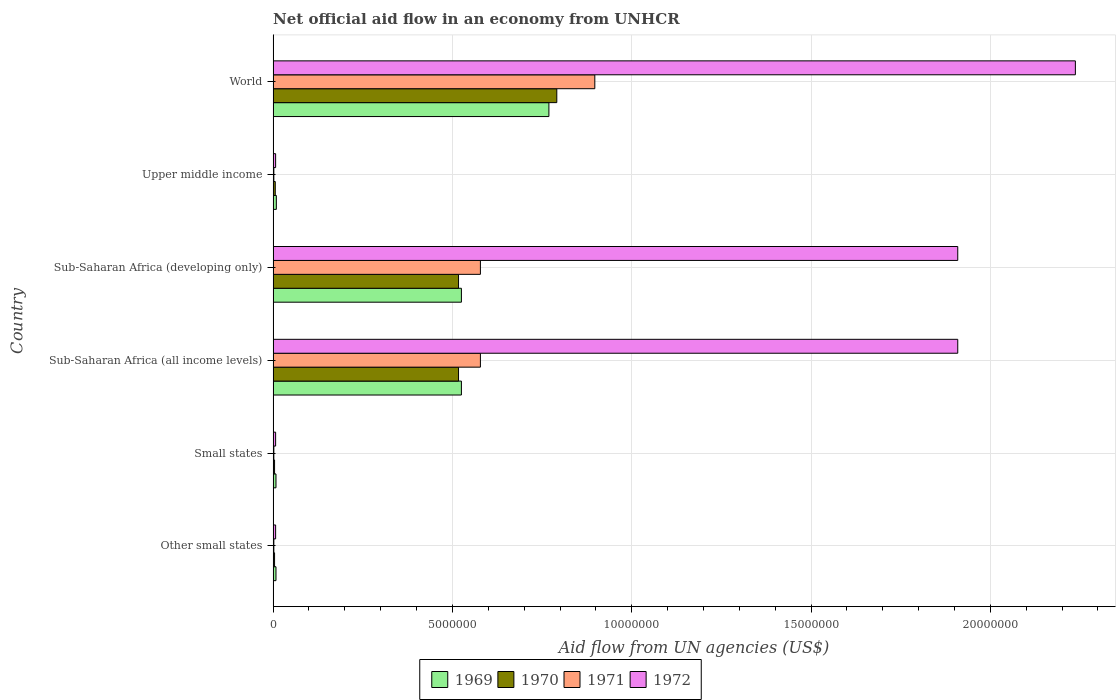How many groups of bars are there?
Provide a succinct answer. 6. Are the number of bars per tick equal to the number of legend labels?
Provide a short and direct response. Yes. How many bars are there on the 4th tick from the top?
Provide a succinct answer. 4. How many bars are there on the 2nd tick from the bottom?
Make the answer very short. 4. What is the label of the 1st group of bars from the top?
Provide a short and direct response. World. In how many cases, is the number of bars for a given country not equal to the number of legend labels?
Ensure brevity in your answer.  0. What is the net official aid flow in 1971 in Sub-Saharan Africa (all income levels)?
Keep it short and to the point. 5.78e+06. Across all countries, what is the maximum net official aid flow in 1972?
Your answer should be compact. 2.24e+07. Across all countries, what is the minimum net official aid flow in 1969?
Keep it short and to the point. 8.00e+04. In which country was the net official aid flow in 1971 maximum?
Keep it short and to the point. World. In which country was the net official aid flow in 1972 minimum?
Your response must be concise. Other small states. What is the total net official aid flow in 1971 in the graph?
Your answer should be compact. 2.06e+07. What is the difference between the net official aid flow in 1970 in Sub-Saharan Africa (developing only) and that in World?
Give a very brief answer. -2.74e+06. What is the difference between the net official aid flow in 1970 in Sub-Saharan Africa (all income levels) and the net official aid flow in 1969 in Upper middle income?
Ensure brevity in your answer.  5.08e+06. What is the average net official aid flow in 1971 per country?
Provide a succinct answer. 3.43e+06. What is the ratio of the net official aid flow in 1971 in Small states to that in World?
Your response must be concise. 0. Is the difference between the net official aid flow in 1971 in Sub-Saharan Africa (all income levels) and Sub-Saharan Africa (developing only) greater than the difference between the net official aid flow in 1972 in Sub-Saharan Africa (all income levels) and Sub-Saharan Africa (developing only)?
Provide a succinct answer. No. What is the difference between the highest and the second highest net official aid flow in 1970?
Provide a short and direct response. 2.74e+06. What is the difference between the highest and the lowest net official aid flow in 1972?
Ensure brevity in your answer.  2.23e+07. In how many countries, is the net official aid flow in 1971 greater than the average net official aid flow in 1971 taken over all countries?
Your response must be concise. 3. Is the sum of the net official aid flow in 1970 in Other small states and Sub-Saharan Africa (all income levels) greater than the maximum net official aid flow in 1972 across all countries?
Provide a succinct answer. No. Is it the case that in every country, the sum of the net official aid flow in 1969 and net official aid flow in 1972 is greater than the sum of net official aid flow in 1970 and net official aid flow in 1971?
Keep it short and to the point. No. What does the 4th bar from the top in World represents?
Provide a succinct answer. 1969. What does the 2nd bar from the bottom in World represents?
Your answer should be compact. 1970. Is it the case that in every country, the sum of the net official aid flow in 1969 and net official aid flow in 1970 is greater than the net official aid flow in 1971?
Give a very brief answer. Yes. Are all the bars in the graph horizontal?
Give a very brief answer. Yes. Are the values on the major ticks of X-axis written in scientific E-notation?
Ensure brevity in your answer.  No. Does the graph contain grids?
Provide a short and direct response. Yes. Where does the legend appear in the graph?
Make the answer very short. Bottom center. How many legend labels are there?
Make the answer very short. 4. What is the title of the graph?
Provide a succinct answer. Net official aid flow in an economy from UNHCR. Does "2009" appear as one of the legend labels in the graph?
Your answer should be very brief. No. What is the label or title of the X-axis?
Offer a terse response. Aid flow from UN agencies (US$). What is the label or title of the Y-axis?
Your answer should be compact. Country. What is the Aid flow from UN agencies (US$) of 1970 in Other small states?
Ensure brevity in your answer.  4.00e+04. What is the Aid flow from UN agencies (US$) in 1972 in Other small states?
Your answer should be very brief. 7.00e+04. What is the Aid flow from UN agencies (US$) of 1970 in Small states?
Keep it short and to the point. 4.00e+04. What is the Aid flow from UN agencies (US$) in 1971 in Small states?
Ensure brevity in your answer.  2.00e+04. What is the Aid flow from UN agencies (US$) of 1969 in Sub-Saharan Africa (all income levels)?
Ensure brevity in your answer.  5.25e+06. What is the Aid flow from UN agencies (US$) in 1970 in Sub-Saharan Africa (all income levels)?
Keep it short and to the point. 5.17e+06. What is the Aid flow from UN agencies (US$) of 1971 in Sub-Saharan Africa (all income levels)?
Keep it short and to the point. 5.78e+06. What is the Aid flow from UN agencies (US$) in 1972 in Sub-Saharan Africa (all income levels)?
Offer a very short reply. 1.91e+07. What is the Aid flow from UN agencies (US$) in 1969 in Sub-Saharan Africa (developing only)?
Make the answer very short. 5.25e+06. What is the Aid flow from UN agencies (US$) of 1970 in Sub-Saharan Africa (developing only)?
Provide a succinct answer. 5.17e+06. What is the Aid flow from UN agencies (US$) of 1971 in Sub-Saharan Africa (developing only)?
Provide a succinct answer. 5.78e+06. What is the Aid flow from UN agencies (US$) in 1972 in Sub-Saharan Africa (developing only)?
Provide a succinct answer. 1.91e+07. What is the Aid flow from UN agencies (US$) of 1970 in Upper middle income?
Keep it short and to the point. 6.00e+04. What is the Aid flow from UN agencies (US$) in 1969 in World?
Give a very brief answer. 7.69e+06. What is the Aid flow from UN agencies (US$) in 1970 in World?
Your answer should be compact. 7.91e+06. What is the Aid flow from UN agencies (US$) in 1971 in World?
Your answer should be compact. 8.97e+06. What is the Aid flow from UN agencies (US$) in 1972 in World?
Your answer should be compact. 2.24e+07. Across all countries, what is the maximum Aid flow from UN agencies (US$) of 1969?
Offer a terse response. 7.69e+06. Across all countries, what is the maximum Aid flow from UN agencies (US$) of 1970?
Give a very brief answer. 7.91e+06. Across all countries, what is the maximum Aid flow from UN agencies (US$) of 1971?
Give a very brief answer. 8.97e+06. Across all countries, what is the maximum Aid flow from UN agencies (US$) in 1972?
Your answer should be very brief. 2.24e+07. What is the total Aid flow from UN agencies (US$) in 1969 in the graph?
Give a very brief answer. 1.84e+07. What is the total Aid flow from UN agencies (US$) in 1970 in the graph?
Your answer should be very brief. 1.84e+07. What is the total Aid flow from UN agencies (US$) of 1971 in the graph?
Offer a very short reply. 2.06e+07. What is the total Aid flow from UN agencies (US$) of 1972 in the graph?
Your answer should be very brief. 6.08e+07. What is the difference between the Aid flow from UN agencies (US$) of 1969 in Other small states and that in Sub-Saharan Africa (all income levels)?
Your answer should be compact. -5.17e+06. What is the difference between the Aid flow from UN agencies (US$) of 1970 in Other small states and that in Sub-Saharan Africa (all income levels)?
Keep it short and to the point. -5.13e+06. What is the difference between the Aid flow from UN agencies (US$) of 1971 in Other small states and that in Sub-Saharan Africa (all income levels)?
Offer a very short reply. -5.76e+06. What is the difference between the Aid flow from UN agencies (US$) of 1972 in Other small states and that in Sub-Saharan Africa (all income levels)?
Keep it short and to the point. -1.90e+07. What is the difference between the Aid flow from UN agencies (US$) of 1969 in Other small states and that in Sub-Saharan Africa (developing only)?
Your answer should be compact. -5.17e+06. What is the difference between the Aid flow from UN agencies (US$) of 1970 in Other small states and that in Sub-Saharan Africa (developing only)?
Ensure brevity in your answer.  -5.13e+06. What is the difference between the Aid flow from UN agencies (US$) of 1971 in Other small states and that in Sub-Saharan Africa (developing only)?
Give a very brief answer. -5.76e+06. What is the difference between the Aid flow from UN agencies (US$) in 1972 in Other small states and that in Sub-Saharan Africa (developing only)?
Make the answer very short. -1.90e+07. What is the difference between the Aid flow from UN agencies (US$) in 1971 in Other small states and that in Upper middle income?
Provide a succinct answer. 0. What is the difference between the Aid flow from UN agencies (US$) in 1972 in Other small states and that in Upper middle income?
Offer a very short reply. 0. What is the difference between the Aid flow from UN agencies (US$) in 1969 in Other small states and that in World?
Provide a short and direct response. -7.61e+06. What is the difference between the Aid flow from UN agencies (US$) of 1970 in Other small states and that in World?
Your response must be concise. -7.87e+06. What is the difference between the Aid flow from UN agencies (US$) of 1971 in Other small states and that in World?
Provide a succinct answer. -8.95e+06. What is the difference between the Aid flow from UN agencies (US$) in 1972 in Other small states and that in World?
Make the answer very short. -2.23e+07. What is the difference between the Aid flow from UN agencies (US$) in 1969 in Small states and that in Sub-Saharan Africa (all income levels)?
Offer a terse response. -5.17e+06. What is the difference between the Aid flow from UN agencies (US$) of 1970 in Small states and that in Sub-Saharan Africa (all income levels)?
Your answer should be compact. -5.13e+06. What is the difference between the Aid flow from UN agencies (US$) of 1971 in Small states and that in Sub-Saharan Africa (all income levels)?
Your answer should be compact. -5.76e+06. What is the difference between the Aid flow from UN agencies (US$) in 1972 in Small states and that in Sub-Saharan Africa (all income levels)?
Ensure brevity in your answer.  -1.90e+07. What is the difference between the Aid flow from UN agencies (US$) of 1969 in Small states and that in Sub-Saharan Africa (developing only)?
Offer a terse response. -5.17e+06. What is the difference between the Aid flow from UN agencies (US$) in 1970 in Small states and that in Sub-Saharan Africa (developing only)?
Offer a terse response. -5.13e+06. What is the difference between the Aid flow from UN agencies (US$) of 1971 in Small states and that in Sub-Saharan Africa (developing only)?
Your answer should be compact. -5.76e+06. What is the difference between the Aid flow from UN agencies (US$) of 1972 in Small states and that in Sub-Saharan Africa (developing only)?
Offer a very short reply. -1.90e+07. What is the difference between the Aid flow from UN agencies (US$) of 1971 in Small states and that in Upper middle income?
Your answer should be compact. 0. What is the difference between the Aid flow from UN agencies (US$) of 1972 in Small states and that in Upper middle income?
Your response must be concise. 0. What is the difference between the Aid flow from UN agencies (US$) of 1969 in Small states and that in World?
Your response must be concise. -7.61e+06. What is the difference between the Aid flow from UN agencies (US$) in 1970 in Small states and that in World?
Offer a very short reply. -7.87e+06. What is the difference between the Aid flow from UN agencies (US$) in 1971 in Small states and that in World?
Your response must be concise. -8.95e+06. What is the difference between the Aid flow from UN agencies (US$) in 1972 in Small states and that in World?
Offer a very short reply. -2.23e+07. What is the difference between the Aid flow from UN agencies (US$) in 1971 in Sub-Saharan Africa (all income levels) and that in Sub-Saharan Africa (developing only)?
Offer a terse response. 0. What is the difference between the Aid flow from UN agencies (US$) in 1972 in Sub-Saharan Africa (all income levels) and that in Sub-Saharan Africa (developing only)?
Your response must be concise. 0. What is the difference between the Aid flow from UN agencies (US$) in 1969 in Sub-Saharan Africa (all income levels) and that in Upper middle income?
Provide a succinct answer. 5.16e+06. What is the difference between the Aid flow from UN agencies (US$) of 1970 in Sub-Saharan Africa (all income levels) and that in Upper middle income?
Make the answer very short. 5.11e+06. What is the difference between the Aid flow from UN agencies (US$) of 1971 in Sub-Saharan Africa (all income levels) and that in Upper middle income?
Your answer should be compact. 5.76e+06. What is the difference between the Aid flow from UN agencies (US$) of 1972 in Sub-Saharan Africa (all income levels) and that in Upper middle income?
Keep it short and to the point. 1.90e+07. What is the difference between the Aid flow from UN agencies (US$) of 1969 in Sub-Saharan Africa (all income levels) and that in World?
Keep it short and to the point. -2.44e+06. What is the difference between the Aid flow from UN agencies (US$) in 1970 in Sub-Saharan Africa (all income levels) and that in World?
Make the answer very short. -2.74e+06. What is the difference between the Aid flow from UN agencies (US$) in 1971 in Sub-Saharan Africa (all income levels) and that in World?
Your answer should be compact. -3.19e+06. What is the difference between the Aid flow from UN agencies (US$) in 1972 in Sub-Saharan Africa (all income levels) and that in World?
Your answer should be very brief. -3.28e+06. What is the difference between the Aid flow from UN agencies (US$) of 1969 in Sub-Saharan Africa (developing only) and that in Upper middle income?
Your response must be concise. 5.16e+06. What is the difference between the Aid flow from UN agencies (US$) in 1970 in Sub-Saharan Africa (developing only) and that in Upper middle income?
Your response must be concise. 5.11e+06. What is the difference between the Aid flow from UN agencies (US$) in 1971 in Sub-Saharan Africa (developing only) and that in Upper middle income?
Your response must be concise. 5.76e+06. What is the difference between the Aid flow from UN agencies (US$) in 1972 in Sub-Saharan Africa (developing only) and that in Upper middle income?
Your answer should be very brief. 1.90e+07. What is the difference between the Aid flow from UN agencies (US$) in 1969 in Sub-Saharan Africa (developing only) and that in World?
Ensure brevity in your answer.  -2.44e+06. What is the difference between the Aid flow from UN agencies (US$) in 1970 in Sub-Saharan Africa (developing only) and that in World?
Offer a terse response. -2.74e+06. What is the difference between the Aid flow from UN agencies (US$) of 1971 in Sub-Saharan Africa (developing only) and that in World?
Offer a terse response. -3.19e+06. What is the difference between the Aid flow from UN agencies (US$) of 1972 in Sub-Saharan Africa (developing only) and that in World?
Provide a short and direct response. -3.28e+06. What is the difference between the Aid flow from UN agencies (US$) of 1969 in Upper middle income and that in World?
Make the answer very short. -7.60e+06. What is the difference between the Aid flow from UN agencies (US$) of 1970 in Upper middle income and that in World?
Your answer should be very brief. -7.85e+06. What is the difference between the Aid flow from UN agencies (US$) of 1971 in Upper middle income and that in World?
Your response must be concise. -8.95e+06. What is the difference between the Aid flow from UN agencies (US$) in 1972 in Upper middle income and that in World?
Your answer should be very brief. -2.23e+07. What is the difference between the Aid flow from UN agencies (US$) in 1969 in Other small states and the Aid flow from UN agencies (US$) in 1972 in Small states?
Make the answer very short. 10000. What is the difference between the Aid flow from UN agencies (US$) of 1970 in Other small states and the Aid flow from UN agencies (US$) of 1971 in Small states?
Provide a short and direct response. 2.00e+04. What is the difference between the Aid flow from UN agencies (US$) of 1970 in Other small states and the Aid flow from UN agencies (US$) of 1972 in Small states?
Give a very brief answer. -3.00e+04. What is the difference between the Aid flow from UN agencies (US$) of 1969 in Other small states and the Aid flow from UN agencies (US$) of 1970 in Sub-Saharan Africa (all income levels)?
Your answer should be very brief. -5.09e+06. What is the difference between the Aid flow from UN agencies (US$) in 1969 in Other small states and the Aid flow from UN agencies (US$) in 1971 in Sub-Saharan Africa (all income levels)?
Provide a short and direct response. -5.70e+06. What is the difference between the Aid flow from UN agencies (US$) in 1969 in Other small states and the Aid flow from UN agencies (US$) in 1972 in Sub-Saharan Africa (all income levels)?
Provide a short and direct response. -1.90e+07. What is the difference between the Aid flow from UN agencies (US$) in 1970 in Other small states and the Aid flow from UN agencies (US$) in 1971 in Sub-Saharan Africa (all income levels)?
Make the answer very short. -5.74e+06. What is the difference between the Aid flow from UN agencies (US$) in 1970 in Other small states and the Aid flow from UN agencies (US$) in 1972 in Sub-Saharan Africa (all income levels)?
Your answer should be very brief. -1.90e+07. What is the difference between the Aid flow from UN agencies (US$) in 1971 in Other small states and the Aid flow from UN agencies (US$) in 1972 in Sub-Saharan Africa (all income levels)?
Ensure brevity in your answer.  -1.91e+07. What is the difference between the Aid flow from UN agencies (US$) in 1969 in Other small states and the Aid flow from UN agencies (US$) in 1970 in Sub-Saharan Africa (developing only)?
Your answer should be very brief. -5.09e+06. What is the difference between the Aid flow from UN agencies (US$) in 1969 in Other small states and the Aid flow from UN agencies (US$) in 1971 in Sub-Saharan Africa (developing only)?
Your response must be concise. -5.70e+06. What is the difference between the Aid flow from UN agencies (US$) in 1969 in Other small states and the Aid flow from UN agencies (US$) in 1972 in Sub-Saharan Africa (developing only)?
Ensure brevity in your answer.  -1.90e+07. What is the difference between the Aid flow from UN agencies (US$) in 1970 in Other small states and the Aid flow from UN agencies (US$) in 1971 in Sub-Saharan Africa (developing only)?
Offer a terse response. -5.74e+06. What is the difference between the Aid flow from UN agencies (US$) in 1970 in Other small states and the Aid flow from UN agencies (US$) in 1972 in Sub-Saharan Africa (developing only)?
Your answer should be compact. -1.90e+07. What is the difference between the Aid flow from UN agencies (US$) of 1971 in Other small states and the Aid flow from UN agencies (US$) of 1972 in Sub-Saharan Africa (developing only)?
Make the answer very short. -1.91e+07. What is the difference between the Aid flow from UN agencies (US$) in 1970 in Other small states and the Aid flow from UN agencies (US$) in 1971 in Upper middle income?
Provide a short and direct response. 2.00e+04. What is the difference between the Aid flow from UN agencies (US$) of 1971 in Other small states and the Aid flow from UN agencies (US$) of 1972 in Upper middle income?
Your answer should be very brief. -5.00e+04. What is the difference between the Aid flow from UN agencies (US$) in 1969 in Other small states and the Aid flow from UN agencies (US$) in 1970 in World?
Your response must be concise. -7.83e+06. What is the difference between the Aid flow from UN agencies (US$) of 1969 in Other small states and the Aid flow from UN agencies (US$) of 1971 in World?
Your answer should be compact. -8.89e+06. What is the difference between the Aid flow from UN agencies (US$) in 1969 in Other small states and the Aid flow from UN agencies (US$) in 1972 in World?
Offer a very short reply. -2.23e+07. What is the difference between the Aid flow from UN agencies (US$) in 1970 in Other small states and the Aid flow from UN agencies (US$) in 1971 in World?
Give a very brief answer. -8.93e+06. What is the difference between the Aid flow from UN agencies (US$) in 1970 in Other small states and the Aid flow from UN agencies (US$) in 1972 in World?
Offer a very short reply. -2.23e+07. What is the difference between the Aid flow from UN agencies (US$) of 1971 in Other small states and the Aid flow from UN agencies (US$) of 1972 in World?
Keep it short and to the point. -2.24e+07. What is the difference between the Aid flow from UN agencies (US$) of 1969 in Small states and the Aid flow from UN agencies (US$) of 1970 in Sub-Saharan Africa (all income levels)?
Provide a short and direct response. -5.09e+06. What is the difference between the Aid flow from UN agencies (US$) of 1969 in Small states and the Aid flow from UN agencies (US$) of 1971 in Sub-Saharan Africa (all income levels)?
Provide a succinct answer. -5.70e+06. What is the difference between the Aid flow from UN agencies (US$) of 1969 in Small states and the Aid flow from UN agencies (US$) of 1972 in Sub-Saharan Africa (all income levels)?
Ensure brevity in your answer.  -1.90e+07. What is the difference between the Aid flow from UN agencies (US$) in 1970 in Small states and the Aid flow from UN agencies (US$) in 1971 in Sub-Saharan Africa (all income levels)?
Offer a terse response. -5.74e+06. What is the difference between the Aid flow from UN agencies (US$) in 1970 in Small states and the Aid flow from UN agencies (US$) in 1972 in Sub-Saharan Africa (all income levels)?
Your response must be concise. -1.90e+07. What is the difference between the Aid flow from UN agencies (US$) of 1971 in Small states and the Aid flow from UN agencies (US$) of 1972 in Sub-Saharan Africa (all income levels)?
Your answer should be very brief. -1.91e+07. What is the difference between the Aid flow from UN agencies (US$) in 1969 in Small states and the Aid flow from UN agencies (US$) in 1970 in Sub-Saharan Africa (developing only)?
Offer a terse response. -5.09e+06. What is the difference between the Aid flow from UN agencies (US$) of 1969 in Small states and the Aid flow from UN agencies (US$) of 1971 in Sub-Saharan Africa (developing only)?
Your response must be concise. -5.70e+06. What is the difference between the Aid flow from UN agencies (US$) in 1969 in Small states and the Aid flow from UN agencies (US$) in 1972 in Sub-Saharan Africa (developing only)?
Offer a terse response. -1.90e+07. What is the difference between the Aid flow from UN agencies (US$) in 1970 in Small states and the Aid flow from UN agencies (US$) in 1971 in Sub-Saharan Africa (developing only)?
Provide a succinct answer. -5.74e+06. What is the difference between the Aid flow from UN agencies (US$) in 1970 in Small states and the Aid flow from UN agencies (US$) in 1972 in Sub-Saharan Africa (developing only)?
Give a very brief answer. -1.90e+07. What is the difference between the Aid flow from UN agencies (US$) of 1971 in Small states and the Aid flow from UN agencies (US$) of 1972 in Sub-Saharan Africa (developing only)?
Offer a terse response. -1.91e+07. What is the difference between the Aid flow from UN agencies (US$) in 1969 in Small states and the Aid flow from UN agencies (US$) in 1970 in Upper middle income?
Offer a very short reply. 2.00e+04. What is the difference between the Aid flow from UN agencies (US$) in 1970 in Small states and the Aid flow from UN agencies (US$) in 1971 in Upper middle income?
Your answer should be compact. 2.00e+04. What is the difference between the Aid flow from UN agencies (US$) of 1970 in Small states and the Aid flow from UN agencies (US$) of 1972 in Upper middle income?
Your answer should be very brief. -3.00e+04. What is the difference between the Aid flow from UN agencies (US$) in 1971 in Small states and the Aid flow from UN agencies (US$) in 1972 in Upper middle income?
Give a very brief answer. -5.00e+04. What is the difference between the Aid flow from UN agencies (US$) in 1969 in Small states and the Aid flow from UN agencies (US$) in 1970 in World?
Offer a terse response. -7.83e+06. What is the difference between the Aid flow from UN agencies (US$) of 1969 in Small states and the Aid flow from UN agencies (US$) of 1971 in World?
Provide a succinct answer. -8.89e+06. What is the difference between the Aid flow from UN agencies (US$) of 1969 in Small states and the Aid flow from UN agencies (US$) of 1972 in World?
Ensure brevity in your answer.  -2.23e+07. What is the difference between the Aid flow from UN agencies (US$) in 1970 in Small states and the Aid flow from UN agencies (US$) in 1971 in World?
Provide a short and direct response. -8.93e+06. What is the difference between the Aid flow from UN agencies (US$) in 1970 in Small states and the Aid flow from UN agencies (US$) in 1972 in World?
Offer a terse response. -2.23e+07. What is the difference between the Aid flow from UN agencies (US$) of 1971 in Small states and the Aid flow from UN agencies (US$) of 1972 in World?
Your answer should be very brief. -2.24e+07. What is the difference between the Aid flow from UN agencies (US$) in 1969 in Sub-Saharan Africa (all income levels) and the Aid flow from UN agencies (US$) in 1971 in Sub-Saharan Africa (developing only)?
Your answer should be compact. -5.30e+05. What is the difference between the Aid flow from UN agencies (US$) in 1969 in Sub-Saharan Africa (all income levels) and the Aid flow from UN agencies (US$) in 1972 in Sub-Saharan Africa (developing only)?
Your response must be concise. -1.38e+07. What is the difference between the Aid flow from UN agencies (US$) in 1970 in Sub-Saharan Africa (all income levels) and the Aid flow from UN agencies (US$) in 1971 in Sub-Saharan Africa (developing only)?
Provide a succinct answer. -6.10e+05. What is the difference between the Aid flow from UN agencies (US$) in 1970 in Sub-Saharan Africa (all income levels) and the Aid flow from UN agencies (US$) in 1972 in Sub-Saharan Africa (developing only)?
Offer a very short reply. -1.39e+07. What is the difference between the Aid flow from UN agencies (US$) in 1971 in Sub-Saharan Africa (all income levels) and the Aid flow from UN agencies (US$) in 1972 in Sub-Saharan Africa (developing only)?
Give a very brief answer. -1.33e+07. What is the difference between the Aid flow from UN agencies (US$) in 1969 in Sub-Saharan Africa (all income levels) and the Aid flow from UN agencies (US$) in 1970 in Upper middle income?
Ensure brevity in your answer.  5.19e+06. What is the difference between the Aid flow from UN agencies (US$) in 1969 in Sub-Saharan Africa (all income levels) and the Aid flow from UN agencies (US$) in 1971 in Upper middle income?
Provide a short and direct response. 5.23e+06. What is the difference between the Aid flow from UN agencies (US$) of 1969 in Sub-Saharan Africa (all income levels) and the Aid flow from UN agencies (US$) of 1972 in Upper middle income?
Provide a short and direct response. 5.18e+06. What is the difference between the Aid flow from UN agencies (US$) in 1970 in Sub-Saharan Africa (all income levels) and the Aid flow from UN agencies (US$) in 1971 in Upper middle income?
Your response must be concise. 5.15e+06. What is the difference between the Aid flow from UN agencies (US$) of 1970 in Sub-Saharan Africa (all income levels) and the Aid flow from UN agencies (US$) of 1972 in Upper middle income?
Ensure brevity in your answer.  5.10e+06. What is the difference between the Aid flow from UN agencies (US$) of 1971 in Sub-Saharan Africa (all income levels) and the Aid flow from UN agencies (US$) of 1972 in Upper middle income?
Offer a very short reply. 5.71e+06. What is the difference between the Aid flow from UN agencies (US$) of 1969 in Sub-Saharan Africa (all income levels) and the Aid flow from UN agencies (US$) of 1970 in World?
Your response must be concise. -2.66e+06. What is the difference between the Aid flow from UN agencies (US$) in 1969 in Sub-Saharan Africa (all income levels) and the Aid flow from UN agencies (US$) in 1971 in World?
Offer a very short reply. -3.72e+06. What is the difference between the Aid flow from UN agencies (US$) in 1969 in Sub-Saharan Africa (all income levels) and the Aid flow from UN agencies (US$) in 1972 in World?
Offer a terse response. -1.71e+07. What is the difference between the Aid flow from UN agencies (US$) in 1970 in Sub-Saharan Africa (all income levels) and the Aid flow from UN agencies (US$) in 1971 in World?
Offer a very short reply. -3.80e+06. What is the difference between the Aid flow from UN agencies (US$) in 1970 in Sub-Saharan Africa (all income levels) and the Aid flow from UN agencies (US$) in 1972 in World?
Your response must be concise. -1.72e+07. What is the difference between the Aid flow from UN agencies (US$) of 1971 in Sub-Saharan Africa (all income levels) and the Aid flow from UN agencies (US$) of 1972 in World?
Make the answer very short. -1.66e+07. What is the difference between the Aid flow from UN agencies (US$) of 1969 in Sub-Saharan Africa (developing only) and the Aid flow from UN agencies (US$) of 1970 in Upper middle income?
Your response must be concise. 5.19e+06. What is the difference between the Aid flow from UN agencies (US$) in 1969 in Sub-Saharan Africa (developing only) and the Aid flow from UN agencies (US$) in 1971 in Upper middle income?
Offer a terse response. 5.23e+06. What is the difference between the Aid flow from UN agencies (US$) of 1969 in Sub-Saharan Africa (developing only) and the Aid flow from UN agencies (US$) of 1972 in Upper middle income?
Make the answer very short. 5.18e+06. What is the difference between the Aid flow from UN agencies (US$) in 1970 in Sub-Saharan Africa (developing only) and the Aid flow from UN agencies (US$) in 1971 in Upper middle income?
Keep it short and to the point. 5.15e+06. What is the difference between the Aid flow from UN agencies (US$) in 1970 in Sub-Saharan Africa (developing only) and the Aid flow from UN agencies (US$) in 1972 in Upper middle income?
Your answer should be compact. 5.10e+06. What is the difference between the Aid flow from UN agencies (US$) of 1971 in Sub-Saharan Africa (developing only) and the Aid flow from UN agencies (US$) of 1972 in Upper middle income?
Provide a succinct answer. 5.71e+06. What is the difference between the Aid flow from UN agencies (US$) of 1969 in Sub-Saharan Africa (developing only) and the Aid flow from UN agencies (US$) of 1970 in World?
Keep it short and to the point. -2.66e+06. What is the difference between the Aid flow from UN agencies (US$) of 1969 in Sub-Saharan Africa (developing only) and the Aid flow from UN agencies (US$) of 1971 in World?
Keep it short and to the point. -3.72e+06. What is the difference between the Aid flow from UN agencies (US$) of 1969 in Sub-Saharan Africa (developing only) and the Aid flow from UN agencies (US$) of 1972 in World?
Keep it short and to the point. -1.71e+07. What is the difference between the Aid flow from UN agencies (US$) of 1970 in Sub-Saharan Africa (developing only) and the Aid flow from UN agencies (US$) of 1971 in World?
Provide a short and direct response. -3.80e+06. What is the difference between the Aid flow from UN agencies (US$) in 1970 in Sub-Saharan Africa (developing only) and the Aid flow from UN agencies (US$) in 1972 in World?
Ensure brevity in your answer.  -1.72e+07. What is the difference between the Aid flow from UN agencies (US$) of 1971 in Sub-Saharan Africa (developing only) and the Aid flow from UN agencies (US$) of 1972 in World?
Keep it short and to the point. -1.66e+07. What is the difference between the Aid flow from UN agencies (US$) in 1969 in Upper middle income and the Aid flow from UN agencies (US$) in 1970 in World?
Ensure brevity in your answer.  -7.82e+06. What is the difference between the Aid flow from UN agencies (US$) of 1969 in Upper middle income and the Aid flow from UN agencies (US$) of 1971 in World?
Provide a succinct answer. -8.88e+06. What is the difference between the Aid flow from UN agencies (US$) of 1969 in Upper middle income and the Aid flow from UN agencies (US$) of 1972 in World?
Keep it short and to the point. -2.23e+07. What is the difference between the Aid flow from UN agencies (US$) of 1970 in Upper middle income and the Aid flow from UN agencies (US$) of 1971 in World?
Keep it short and to the point. -8.91e+06. What is the difference between the Aid flow from UN agencies (US$) in 1970 in Upper middle income and the Aid flow from UN agencies (US$) in 1972 in World?
Your answer should be very brief. -2.23e+07. What is the difference between the Aid flow from UN agencies (US$) in 1971 in Upper middle income and the Aid flow from UN agencies (US$) in 1972 in World?
Provide a short and direct response. -2.24e+07. What is the average Aid flow from UN agencies (US$) of 1969 per country?
Make the answer very short. 3.07e+06. What is the average Aid flow from UN agencies (US$) in 1970 per country?
Provide a short and direct response. 3.06e+06. What is the average Aid flow from UN agencies (US$) in 1971 per country?
Your answer should be compact. 3.43e+06. What is the average Aid flow from UN agencies (US$) of 1972 per country?
Make the answer very short. 1.01e+07. What is the difference between the Aid flow from UN agencies (US$) in 1969 and Aid flow from UN agencies (US$) in 1972 in Other small states?
Your answer should be compact. 10000. What is the difference between the Aid flow from UN agencies (US$) of 1970 and Aid flow from UN agencies (US$) of 1971 in Other small states?
Provide a succinct answer. 2.00e+04. What is the difference between the Aid flow from UN agencies (US$) in 1971 and Aid flow from UN agencies (US$) in 1972 in Other small states?
Keep it short and to the point. -5.00e+04. What is the difference between the Aid flow from UN agencies (US$) in 1969 and Aid flow from UN agencies (US$) in 1970 in Small states?
Make the answer very short. 4.00e+04. What is the difference between the Aid flow from UN agencies (US$) in 1969 and Aid flow from UN agencies (US$) in 1972 in Small states?
Keep it short and to the point. 10000. What is the difference between the Aid flow from UN agencies (US$) in 1970 and Aid flow from UN agencies (US$) in 1972 in Small states?
Your answer should be very brief. -3.00e+04. What is the difference between the Aid flow from UN agencies (US$) in 1969 and Aid flow from UN agencies (US$) in 1971 in Sub-Saharan Africa (all income levels)?
Provide a short and direct response. -5.30e+05. What is the difference between the Aid flow from UN agencies (US$) of 1969 and Aid flow from UN agencies (US$) of 1972 in Sub-Saharan Africa (all income levels)?
Make the answer very short. -1.38e+07. What is the difference between the Aid flow from UN agencies (US$) in 1970 and Aid flow from UN agencies (US$) in 1971 in Sub-Saharan Africa (all income levels)?
Provide a succinct answer. -6.10e+05. What is the difference between the Aid flow from UN agencies (US$) in 1970 and Aid flow from UN agencies (US$) in 1972 in Sub-Saharan Africa (all income levels)?
Offer a terse response. -1.39e+07. What is the difference between the Aid flow from UN agencies (US$) in 1971 and Aid flow from UN agencies (US$) in 1972 in Sub-Saharan Africa (all income levels)?
Provide a succinct answer. -1.33e+07. What is the difference between the Aid flow from UN agencies (US$) of 1969 and Aid flow from UN agencies (US$) of 1971 in Sub-Saharan Africa (developing only)?
Your answer should be very brief. -5.30e+05. What is the difference between the Aid flow from UN agencies (US$) of 1969 and Aid flow from UN agencies (US$) of 1972 in Sub-Saharan Africa (developing only)?
Keep it short and to the point. -1.38e+07. What is the difference between the Aid flow from UN agencies (US$) in 1970 and Aid flow from UN agencies (US$) in 1971 in Sub-Saharan Africa (developing only)?
Provide a short and direct response. -6.10e+05. What is the difference between the Aid flow from UN agencies (US$) in 1970 and Aid flow from UN agencies (US$) in 1972 in Sub-Saharan Africa (developing only)?
Make the answer very short. -1.39e+07. What is the difference between the Aid flow from UN agencies (US$) of 1971 and Aid flow from UN agencies (US$) of 1972 in Sub-Saharan Africa (developing only)?
Offer a terse response. -1.33e+07. What is the difference between the Aid flow from UN agencies (US$) of 1969 and Aid flow from UN agencies (US$) of 1971 in Upper middle income?
Provide a succinct answer. 7.00e+04. What is the difference between the Aid flow from UN agencies (US$) of 1969 and Aid flow from UN agencies (US$) of 1970 in World?
Offer a terse response. -2.20e+05. What is the difference between the Aid flow from UN agencies (US$) of 1969 and Aid flow from UN agencies (US$) of 1971 in World?
Your response must be concise. -1.28e+06. What is the difference between the Aid flow from UN agencies (US$) of 1969 and Aid flow from UN agencies (US$) of 1972 in World?
Keep it short and to the point. -1.47e+07. What is the difference between the Aid flow from UN agencies (US$) of 1970 and Aid flow from UN agencies (US$) of 1971 in World?
Keep it short and to the point. -1.06e+06. What is the difference between the Aid flow from UN agencies (US$) in 1970 and Aid flow from UN agencies (US$) in 1972 in World?
Offer a very short reply. -1.45e+07. What is the difference between the Aid flow from UN agencies (US$) of 1971 and Aid flow from UN agencies (US$) of 1972 in World?
Your response must be concise. -1.34e+07. What is the ratio of the Aid flow from UN agencies (US$) in 1971 in Other small states to that in Small states?
Your answer should be compact. 1. What is the ratio of the Aid flow from UN agencies (US$) of 1969 in Other small states to that in Sub-Saharan Africa (all income levels)?
Provide a short and direct response. 0.02. What is the ratio of the Aid flow from UN agencies (US$) in 1970 in Other small states to that in Sub-Saharan Africa (all income levels)?
Offer a very short reply. 0.01. What is the ratio of the Aid flow from UN agencies (US$) of 1971 in Other small states to that in Sub-Saharan Africa (all income levels)?
Offer a very short reply. 0. What is the ratio of the Aid flow from UN agencies (US$) of 1972 in Other small states to that in Sub-Saharan Africa (all income levels)?
Your answer should be very brief. 0. What is the ratio of the Aid flow from UN agencies (US$) of 1969 in Other small states to that in Sub-Saharan Africa (developing only)?
Your response must be concise. 0.02. What is the ratio of the Aid flow from UN agencies (US$) of 1970 in Other small states to that in Sub-Saharan Africa (developing only)?
Your response must be concise. 0.01. What is the ratio of the Aid flow from UN agencies (US$) of 1971 in Other small states to that in Sub-Saharan Africa (developing only)?
Offer a terse response. 0. What is the ratio of the Aid flow from UN agencies (US$) in 1972 in Other small states to that in Sub-Saharan Africa (developing only)?
Your answer should be compact. 0. What is the ratio of the Aid flow from UN agencies (US$) in 1969 in Other small states to that in Upper middle income?
Provide a short and direct response. 0.89. What is the ratio of the Aid flow from UN agencies (US$) of 1970 in Other small states to that in Upper middle income?
Give a very brief answer. 0.67. What is the ratio of the Aid flow from UN agencies (US$) in 1972 in Other small states to that in Upper middle income?
Your answer should be compact. 1. What is the ratio of the Aid flow from UN agencies (US$) of 1969 in Other small states to that in World?
Ensure brevity in your answer.  0.01. What is the ratio of the Aid flow from UN agencies (US$) in 1970 in Other small states to that in World?
Offer a terse response. 0.01. What is the ratio of the Aid flow from UN agencies (US$) of 1971 in Other small states to that in World?
Your answer should be very brief. 0. What is the ratio of the Aid flow from UN agencies (US$) in 1972 in Other small states to that in World?
Your response must be concise. 0. What is the ratio of the Aid flow from UN agencies (US$) of 1969 in Small states to that in Sub-Saharan Africa (all income levels)?
Offer a very short reply. 0.02. What is the ratio of the Aid flow from UN agencies (US$) of 1970 in Small states to that in Sub-Saharan Africa (all income levels)?
Your response must be concise. 0.01. What is the ratio of the Aid flow from UN agencies (US$) in 1971 in Small states to that in Sub-Saharan Africa (all income levels)?
Offer a terse response. 0. What is the ratio of the Aid flow from UN agencies (US$) in 1972 in Small states to that in Sub-Saharan Africa (all income levels)?
Offer a terse response. 0. What is the ratio of the Aid flow from UN agencies (US$) of 1969 in Small states to that in Sub-Saharan Africa (developing only)?
Keep it short and to the point. 0.02. What is the ratio of the Aid flow from UN agencies (US$) of 1970 in Small states to that in Sub-Saharan Africa (developing only)?
Provide a short and direct response. 0.01. What is the ratio of the Aid flow from UN agencies (US$) in 1971 in Small states to that in Sub-Saharan Africa (developing only)?
Provide a succinct answer. 0. What is the ratio of the Aid flow from UN agencies (US$) in 1972 in Small states to that in Sub-Saharan Africa (developing only)?
Provide a short and direct response. 0. What is the ratio of the Aid flow from UN agencies (US$) in 1969 in Small states to that in Upper middle income?
Offer a terse response. 0.89. What is the ratio of the Aid flow from UN agencies (US$) in 1971 in Small states to that in Upper middle income?
Your answer should be very brief. 1. What is the ratio of the Aid flow from UN agencies (US$) in 1972 in Small states to that in Upper middle income?
Make the answer very short. 1. What is the ratio of the Aid flow from UN agencies (US$) in 1969 in Small states to that in World?
Give a very brief answer. 0.01. What is the ratio of the Aid flow from UN agencies (US$) in 1970 in Small states to that in World?
Ensure brevity in your answer.  0.01. What is the ratio of the Aid flow from UN agencies (US$) in 1971 in Small states to that in World?
Your answer should be very brief. 0. What is the ratio of the Aid flow from UN agencies (US$) in 1972 in Small states to that in World?
Your answer should be very brief. 0. What is the ratio of the Aid flow from UN agencies (US$) in 1969 in Sub-Saharan Africa (all income levels) to that in Sub-Saharan Africa (developing only)?
Keep it short and to the point. 1. What is the ratio of the Aid flow from UN agencies (US$) in 1970 in Sub-Saharan Africa (all income levels) to that in Sub-Saharan Africa (developing only)?
Make the answer very short. 1. What is the ratio of the Aid flow from UN agencies (US$) of 1972 in Sub-Saharan Africa (all income levels) to that in Sub-Saharan Africa (developing only)?
Offer a very short reply. 1. What is the ratio of the Aid flow from UN agencies (US$) of 1969 in Sub-Saharan Africa (all income levels) to that in Upper middle income?
Your answer should be compact. 58.33. What is the ratio of the Aid flow from UN agencies (US$) of 1970 in Sub-Saharan Africa (all income levels) to that in Upper middle income?
Give a very brief answer. 86.17. What is the ratio of the Aid flow from UN agencies (US$) of 1971 in Sub-Saharan Africa (all income levels) to that in Upper middle income?
Offer a very short reply. 289. What is the ratio of the Aid flow from UN agencies (US$) of 1972 in Sub-Saharan Africa (all income levels) to that in Upper middle income?
Make the answer very short. 272.71. What is the ratio of the Aid flow from UN agencies (US$) of 1969 in Sub-Saharan Africa (all income levels) to that in World?
Offer a terse response. 0.68. What is the ratio of the Aid flow from UN agencies (US$) of 1970 in Sub-Saharan Africa (all income levels) to that in World?
Make the answer very short. 0.65. What is the ratio of the Aid flow from UN agencies (US$) of 1971 in Sub-Saharan Africa (all income levels) to that in World?
Give a very brief answer. 0.64. What is the ratio of the Aid flow from UN agencies (US$) of 1972 in Sub-Saharan Africa (all income levels) to that in World?
Offer a terse response. 0.85. What is the ratio of the Aid flow from UN agencies (US$) in 1969 in Sub-Saharan Africa (developing only) to that in Upper middle income?
Offer a very short reply. 58.33. What is the ratio of the Aid flow from UN agencies (US$) in 1970 in Sub-Saharan Africa (developing only) to that in Upper middle income?
Provide a short and direct response. 86.17. What is the ratio of the Aid flow from UN agencies (US$) in 1971 in Sub-Saharan Africa (developing only) to that in Upper middle income?
Give a very brief answer. 289. What is the ratio of the Aid flow from UN agencies (US$) in 1972 in Sub-Saharan Africa (developing only) to that in Upper middle income?
Make the answer very short. 272.71. What is the ratio of the Aid flow from UN agencies (US$) of 1969 in Sub-Saharan Africa (developing only) to that in World?
Offer a terse response. 0.68. What is the ratio of the Aid flow from UN agencies (US$) in 1970 in Sub-Saharan Africa (developing only) to that in World?
Your answer should be compact. 0.65. What is the ratio of the Aid flow from UN agencies (US$) of 1971 in Sub-Saharan Africa (developing only) to that in World?
Keep it short and to the point. 0.64. What is the ratio of the Aid flow from UN agencies (US$) of 1972 in Sub-Saharan Africa (developing only) to that in World?
Ensure brevity in your answer.  0.85. What is the ratio of the Aid flow from UN agencies (US$) of 1969 in Upper middle income to that in World?
Provide a short and direct response. 0.01. What is the ratio of the Aid flow from UN agencies (US$) of 1970 in Upper middle income to that in World?
Provide a short and direct response. 0.01. What is the ratio of the Aid flow from UN agencies (US$) of 1971 in Upper middle income to that in World?
Ensure brevity in your answer.  0. What is the ratio of the Aid flow from UN agencies (US$) of 1972 in Upper middle income to that in World?
Ensure brevity in your answer.  0. What is the difference between the highest and the second highest Aid flow from UN agencies (US$) of 1969?
Make the answer very short. 2.44e+06. What is the difference between the highest and the second highest Aid flow from UN agencies (US$) of 1970?
Offer a terse response. 2.74e+06. What is the difference between the highest and the second highest Aid flow from UN agencies (US$) of 1971?
Give a very brief answer. 3.19e+06. What is the difference between the highest and the second highest Aid flow from UN agencies (US$) in 1972?
Offer a very short reply. 3.28e+06. What is the difference between the highest and the lowest Aid flow from UN agencies (US$) in 1969?
Your answer should be compact. 7.61e+06. What is the difference between the highest and the lowest Aid flow from UN agencies (US$) in 1970?
Your response must be concise. 7.87e+06. What is the difference between the highest and the lowest Aid flow from UN agencies (US$) of 1971?
Your response must be concise. 8.95e+06. What is the difference between the highest and the lowest Aid flow from UN agencies (US$) in 1972?
Provide a short and direct response. 2.23e+07. 